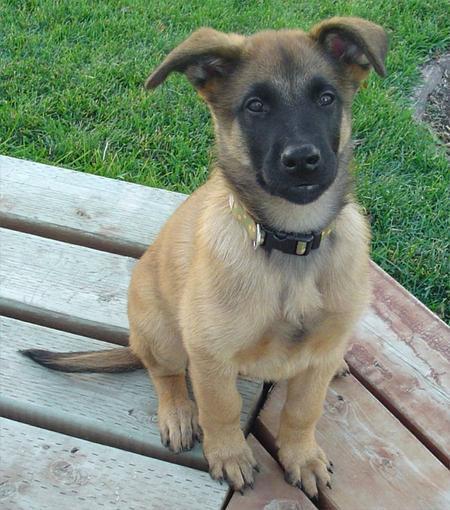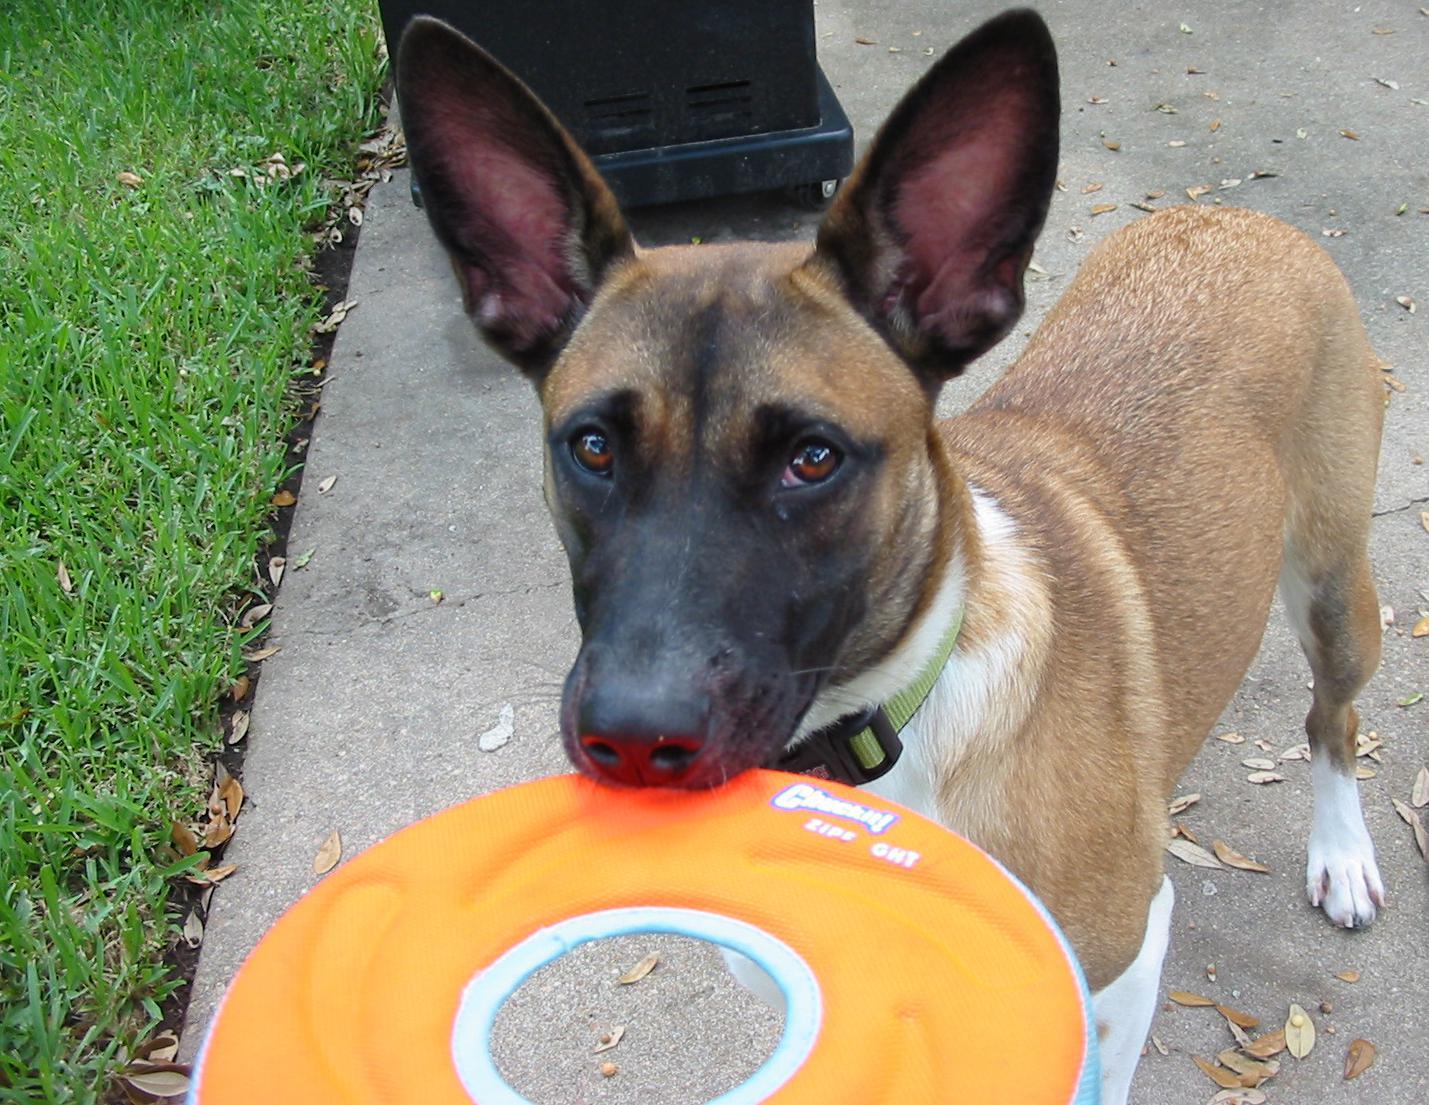The first image is the image on the left, the second image is the image on the right. For the images displayed, is the sentence "the puppy is sitting on a wooden platform" factually correct? Answer yes or no. Yes. The first image is the image on the left, the second image is the image on the right. Analyze the images presented: Is the assertion "A dog is carrying something in its mouth" valid? Answer yes or no. Yes. 